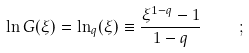Convert formula to latex. <formula><loc_0><loc_0><loc_500><loc_500>\ln G ( \xi ) = \ln _ { q } ( \xi ) \equiv \frac { \xi ^ { 1 - q } - 1 } { 1 - q } \quad ;</formula> 